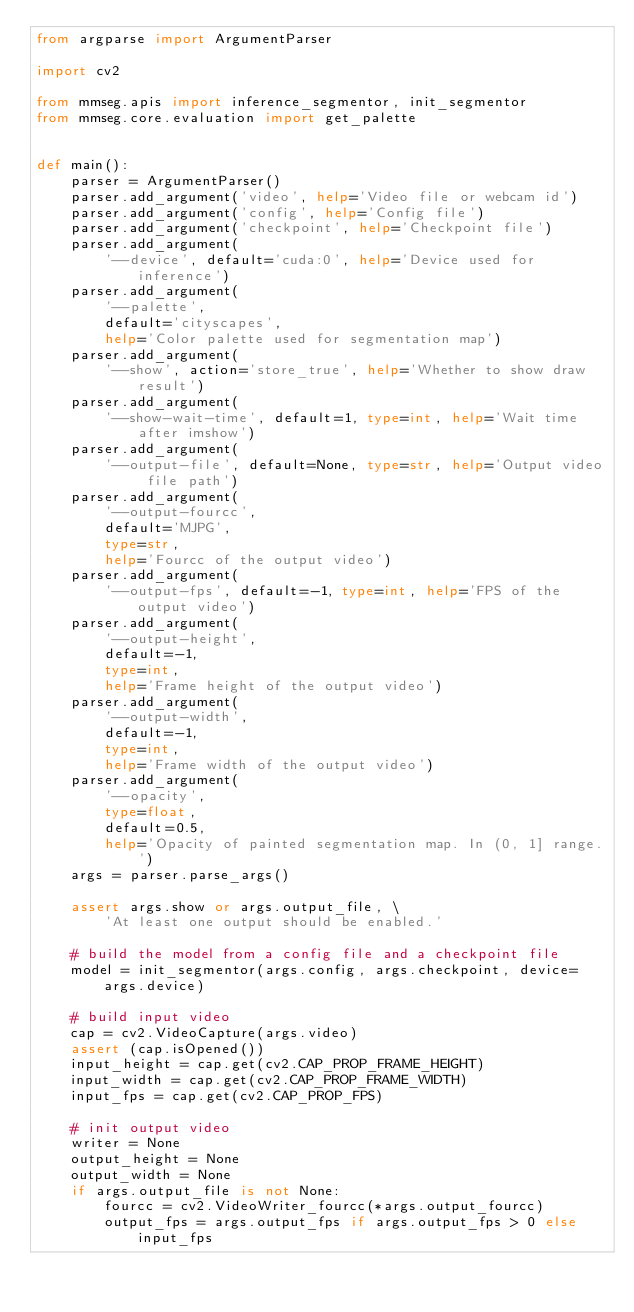Convert code to text. <code><loc_0><loc_0><loc_500><loc_500><_Python_>from argparse import ArgumentParser

import cv2

from mmseg.apis import inference_segmentor, init_segmentor
from mmseg.core.evaluation import get_palette


def main():
    parser = ArgumentParser()
    parser.add_argument('video', help='Video file or webcam id')
    parser.add_argument('config', help='Config file')
    parser.add_argument('checkpoint', help='Checkpoint file')
    parser.add_argument(
        '--device', default='cuda:0', help='Device used for inference')
    parser.add_argument(
        '--palette',
        default='cityscapes',
        help='Color palette used for segmentation map')
    parser.add_argument(
        '--show', action='store_true', help='Whether to show draw result')
    parser.add_argument(
        '--show-wait-time', default=1, type=int, help='Wait time after imshow')
    parser.add_argument(
        '--output-file', default=None, type=str, help='Output video file path')
    parser.add_argument(
        '--output-fourcc',
        default='MJPG',
        type=str,
        help='Fourcc of the output video')
    parser.add_argument(
        '--output-fps', default=-1, type=int, help='FPS of the output video')
    parser.add_argument(
        '--output-height',
        default=-1,
        type=int,
        help='Frame height of the output video')
    parser.add_argument(
        '--output-width',
        default=-1,
        type=int,
        help='Frame width of the output video')
    parser.add_argument(
        '--opacity',
        type=float,
        default=0.5,
        help='Opacity of painted segmentation map. In (0, 1] range.')
    args = parser.parse_args()

    assert args.show or args.output_file, \
        'At least one output should be enabled.'

    # build the model from a config file and a checkpoint file
    model = init_segmentor(args.config, args.checkpoint, device=args.device)

    # build input video
    cap = cv2.VideoCapture(args.video)
    assert (cap.isOpened())
    input_height = cap.get(cv2.CAP_PROP_FRAME_HEIGHT)
    input_width = cap.get(cv2.CAP_PROP_FRAME_WIDTH)
    input_fps = cap.get(cv2.CAP_PROP_FPS)

    # init output video
    writer = None
    output_height = None
    output_width = None
    if args.output_file is not None:
        fourcc = cv2.VideoWriter_fourcc(*args.output_fourcc)
        output_fps = args.output_fps if args.output_fps > 0 else input_fps</code> 